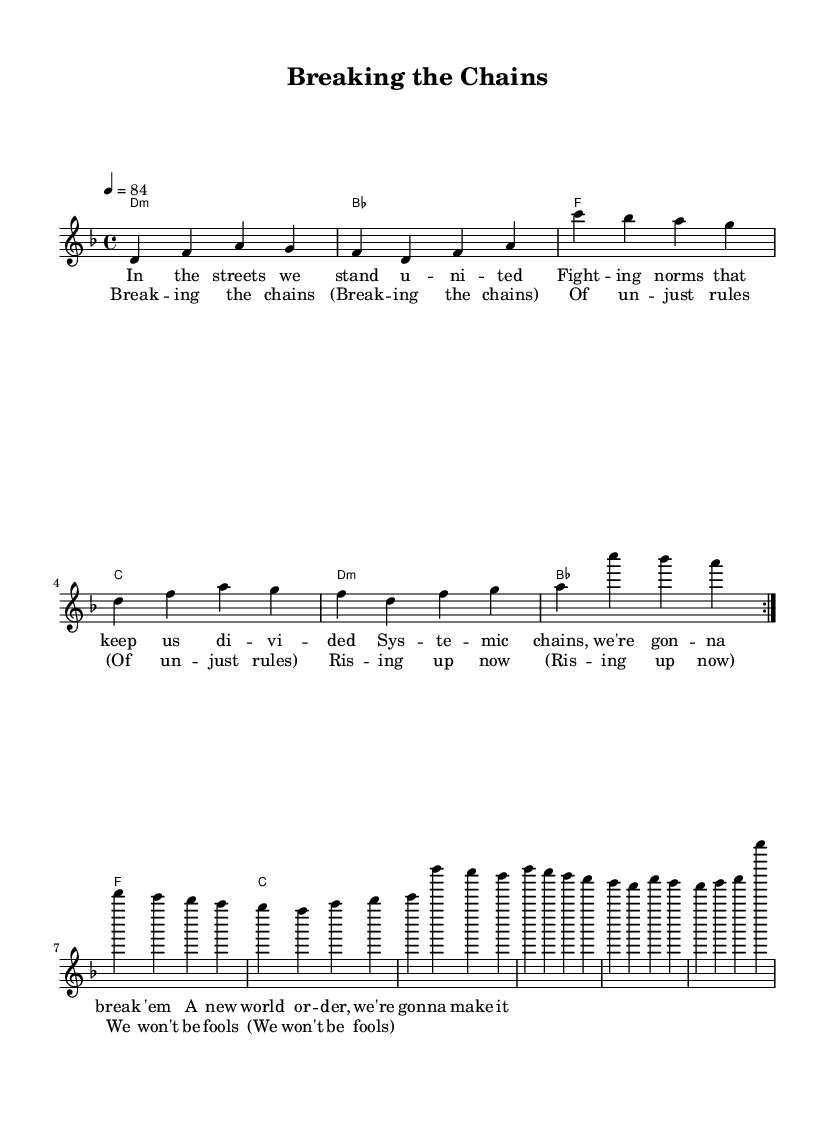What is the key signature of this music? The key signature is D minor, which has one flat. This can be determined from the global section where it specifies \key d \minor.
Answer: D minor What is the time signature? The time signature is 4/4, indicated in the global section of the code where it specifies \time 4/4. This means there are four beats in each measure.
Answer: 4/4 What is the tempo marking? The tempo marking indicates that the music is to be played at a tempo of 84 beats per minute. This is stated in the global section with the tempo set as \tempo 4 = 84.
Answer: 84 How many measures are in the verses? The verses consist of 8 measures in total. Each repeat of the volta contains 4 measures, and there are 2 repeats before the break into the next section.
Answer: 8 What specific theme do the lyrics convey? The lyrics convey themes of unity and social justice, critiquing unjust social norms and systemic inequalities. This can be inferred from the phrases in the lyrics that mention fighting against norms and breaking chains.
Answer: Unity and social justice How does the harmonic structure support the message of the song? The harmonic structure supports the message by using a minor chord progression which can convey a feeling of struggle or tension, consistent with the themes of fighting against unjust rules. The chord progression from D minor to B flat and F creates a sense of movement towards resolution.
Answer: Minor chord progression What is the primary lyrical device used in the chorus? The primary lyrical device used in the chorus is repetition. The phrase "Breaking the chains" is repeated to emphasize the message, making it memorable and impactful.
Answer: Repetition 